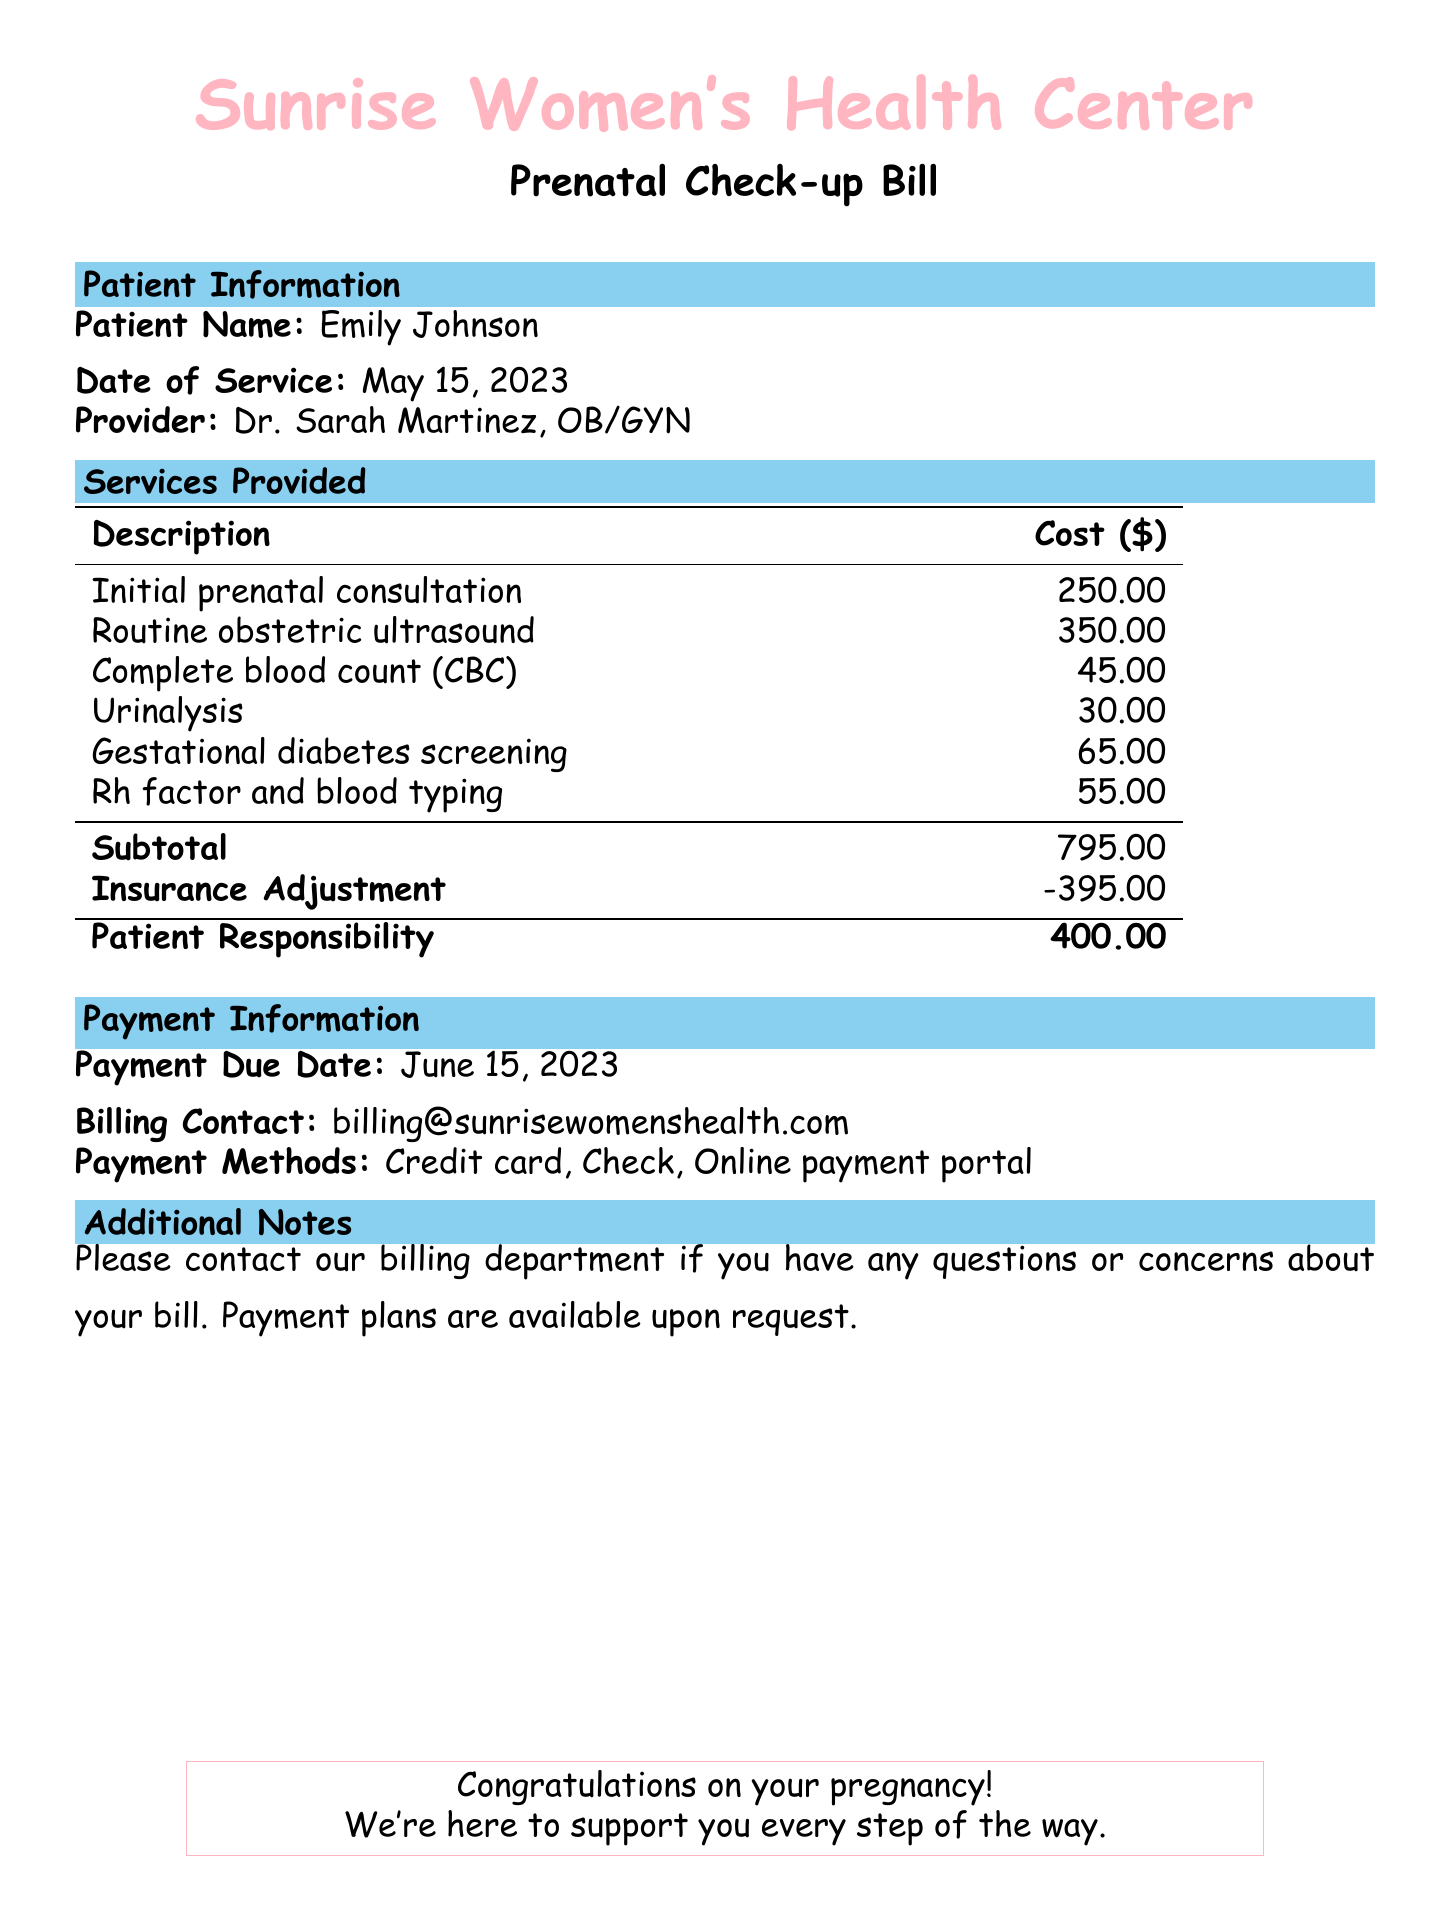What is the patient's name? The patient's name is listed in the patient information section of the document.
Answer: Emily Johnson What is the date of service? The date of service can be found in the patient information section of the bill.
Answer: May 15, 2023 What is the total cost of the ultrasound? The cost of the routine obstetric ultrasound is detailed in the services provided section.
Answer: 350.00 What is the subtotal of the services? The subtotal is a calculation of all costs before any adjustments, found in the services provided section.
Answer: 795.00 What is the insurance adjustment amount? The insurance adjustment amount is provided in the billing breakdown of the document.
Answer: -395.00 How much does the patient owe after adjustments? The patient responsibility is calculated after applying insurance adjustments.
Answer: 400.00 When is the payment due? The payment due date is specified in the payment information section of the bill.
Answer: June 15, 2023 What methods of payment are accepted? The acceptable payment methods are listed in the payment information section.
Answer: Credit card, Check, Online payment portal What should I do if I have questions about my bill? The document includes instructions on how to contact the billing department for inquiries.
Answer: Contact the billing department 